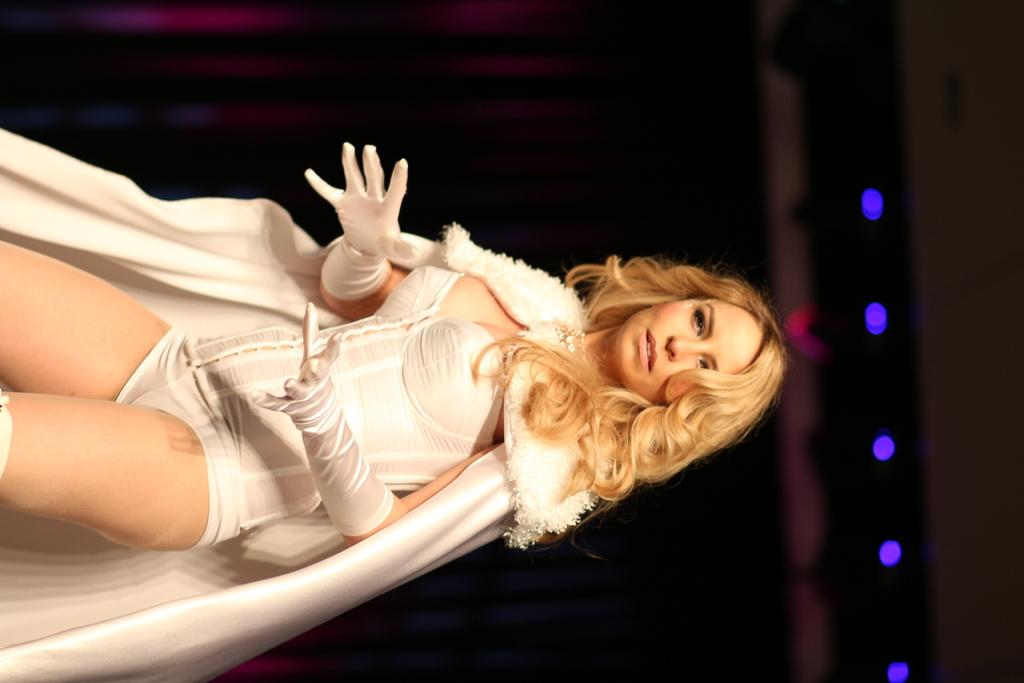What is the main subject of the image? There is a woman standing in the image. Can you describe the background of the image? The background of the image is dark. What can be seen in the background besides the darkness? There are lights visible in the background of the image. What type of jam is the woman spreading on the bread in the image? There is no bread or jam present in the image; it only features a woman standing in a dark background with visible lights. 